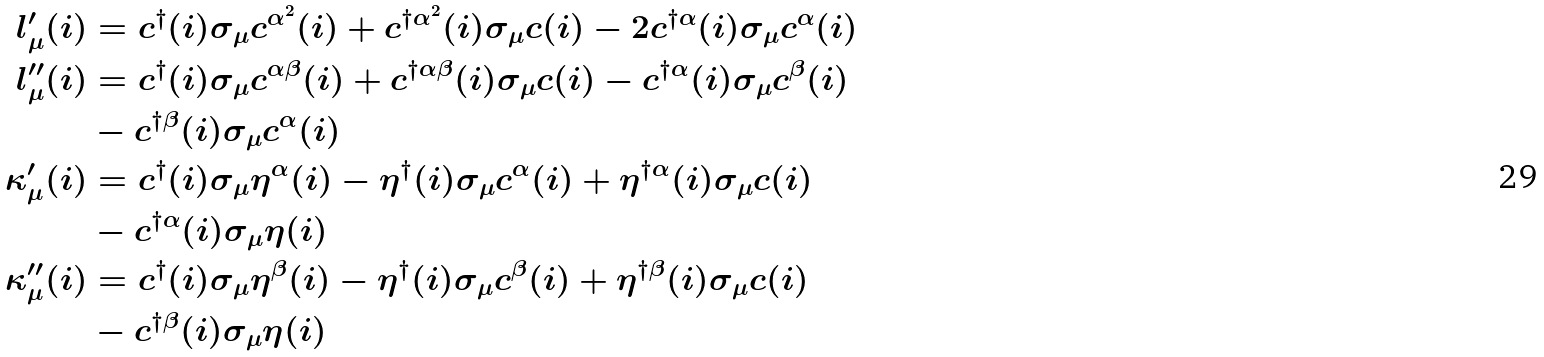<formula> <loc_0><loc_0><loc_500><loc_500>l _ { \mu } ^ { \prime } ( i ) & = c ^ { \dagger } ( i ) \sigma _ { \mu } c ^ { \alpha ^ { 2 } } ( i ) + c ^ { \dagger \alpha ^ { 2 } } ( i ) \sigma _ { \mu } c ( i ) - 2 c ^ { \dagger \alpha } ( i ) \sigma _ { \mu } c ^ { \alpha } ( i ) \\ l _ { \mu } ^ { \prime \prime } ( i ) & = c ^ { \dagger } ( i ) \sigma _ { \mu } c ^ { \alpha \beta } ( i ) + c ^ { \dagger \alpha \beta } ( i ) \sigma _ { \mu } c ( i ) - c ^ { \dagger \alpha } ( i ) \sigma _ { \mu } c ^ { \beta } ( i ) \\ & - c ^ { \dagger \beta } ( i ) \sigma _ { \mu } c ^ { \alpha } ( i ) \\ \kappa _ { \mu } ^ { \prime } ( i ) & = c ^ { \dagger } ( i ) \sigma _ { \mu } \eta ^ { \alpha } ( i ) - \eta ^ { \dagger } ( i ) \sigma _ { \mu } c ^ { \alpha } ( i ) + \eta ^ { \dagger \alpha } ( i ) \sigma _ { \mu } c ( i ) \\ & - c ^ { \dagger \alpha } ( i ) \sigma _ { \mu } \eta ( i ) \\ \kappa _ { \mu } ^ { \prime \prime } ( i ) & = c ^ { \dagger } ( i ) \sigma _ { \mu } \eta ^ { \beta } ( i ) - \eta ^ { \dagger } ( i ) \sigma _ { \mu } c ^ { \beta } ( i ) + \eta ^ { \dagger \beta } ( i ) \sigma _ { \mu } c ( i ) \\ & - c ^ { \dagger \beta } ( i ) \sigma _ { \mu } \eta ( i )</formula> 